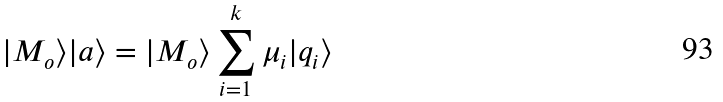Convert formula to latex. <formula><loc_0><loc_0><loc_500><loc_500>| M _ { o } \rangle | a \rangle = | M _ { o } \rangle \sum _ { i = 1 } ^ { k } \mu _ { i } | q _ { i } \rangle</formula> 